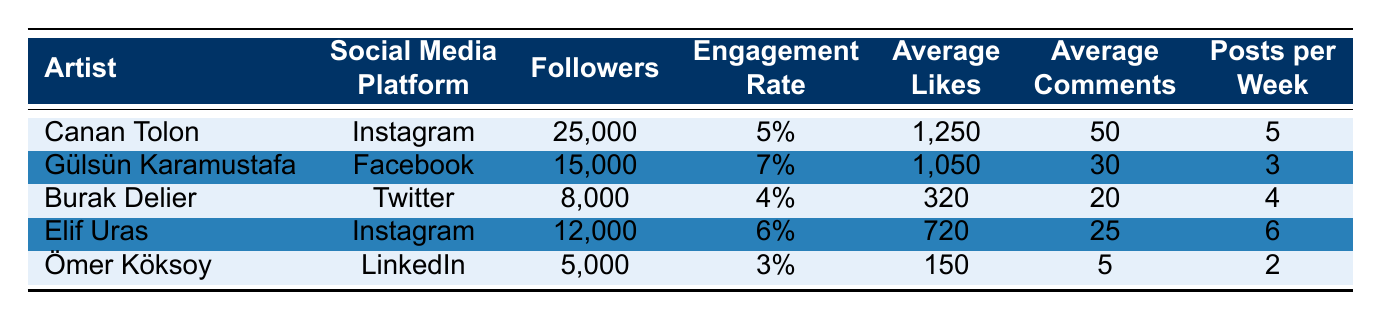What is the engagement rate of Gülsün Karamustafa? According to the table, Gülsün Karamustafa has an engagement rate of 0.07, which translates to 7%.
Answer: 7% How many average likes does Canan Tolon receive per post? The table shows that Canan Tolon receives an average of 1,250 likes per post on Instagram.
Answer: 1,250 Which artist has the highest number of followers? By examining the follower counts, Canan Tolon has 25,000 followers, which is higher than any other artist in the table.
Answer: Canan Tolon What is the average engagement rate of all five artists? The engagement rates are 0.05, 0.07, 0.04, 0.06, and 0.03. Adding these gives 0.25, and dividing by 5 gives an average engagement rate of 0.05 (or 5%).
Answer: 5% Is Ömer Köksoy the artist with the lowest average likes? The average likes for Ömer Köksoy is 150, which is lower than the likes of other artists in the table. For example, Burak Delier has 320 likes, Elif Uras has 720 likes, etc. Thus, the answer is yes.
Answer: Yes What is the difference in followers between Canan Tolon and Burak Delier? Canan Tolon has 25,000 followers and Burak Delier has 8,000 followers. The difference is 25,000 - 8,000 = 17,000 followers.
Answer: 17,000 Does Elif Uras post more frequently than Ömer Köksoy? Elif Uras posts 6 times per week while Ömer Köksoy posts 2 times per week. Therefore, Elif Uras has a higher frequency of posts.
Answer: Yes How many total average comments do the artists generate per week? The average comments per week are 50, 30, 20, 25, and 5. Adding these gives a total of 130 comments generated by the artists per week.
Answer: 130 Which social media platform has the highest engagement rate among the artists listed? Reviewing the engagement rates, Gülsün Karamustafa (Facebook) has the highest engagement rate at 7%, compared to the others.
Answer: Facebook Is the engagement rate of Burak Delier greater than 0.05? Burak Delier's engagement rate is 0.04 (or 4%), which is less than 0.05. Hence, the answer is no.
Answer: No 